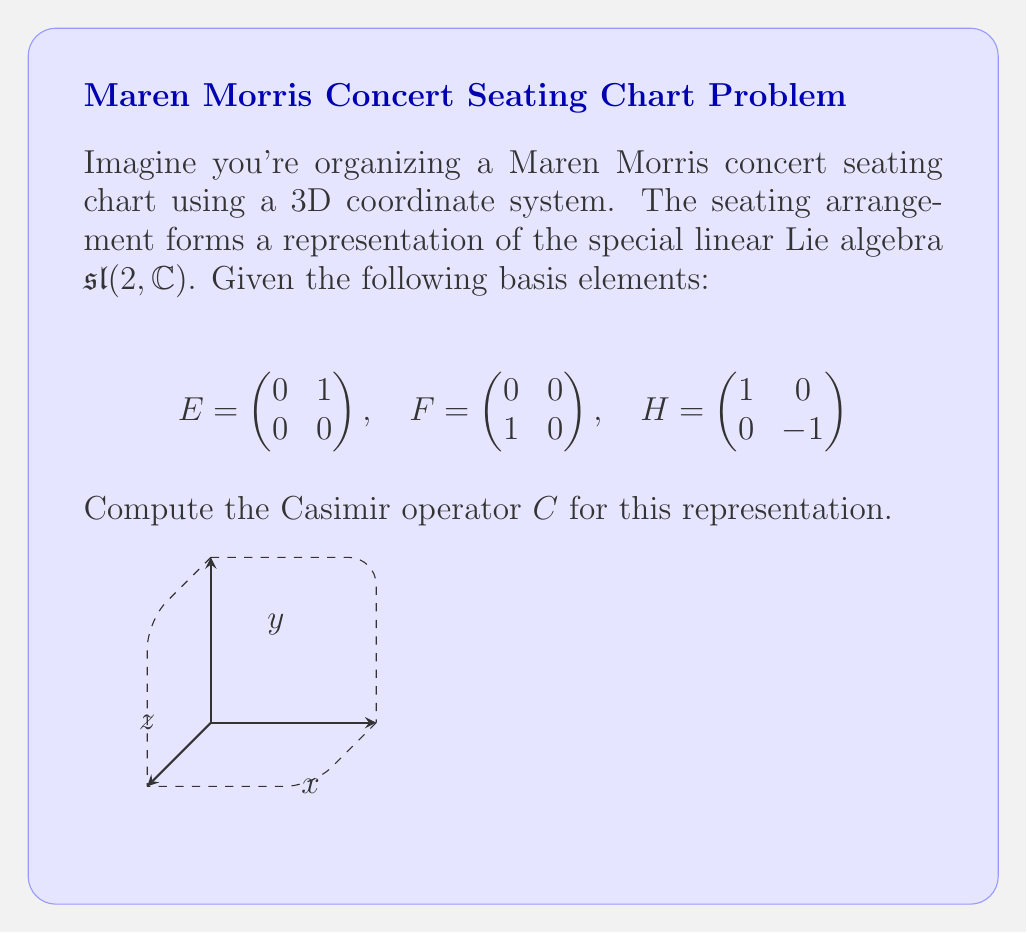Teach me how to tackle this problem. To compute the Casimir operator for this representation of $\mathfrak{sl}(2,\mathbb{C})$, we'll follow these steps:

1) The general form of the Casimir operator for $\mathfrak{sl}(2,\mathbb{C})$ is:

   $$C = H^2 + 2(EF + FE)$$

2) We need to calculate $H^2$, $EF$, and $FE$:

   $H^2 = \begin{pmatrix} 1 & 0 \\ 0 & -1 \end{pmatrix} \begin{pmatrix} 1 & 0 \\ 0 & -1 \end{pmatrix} = \begin{pmatrix} 1 & 0 \\ 0 & 1 \end{pmatrix}$

   $EF = \begin{pmatrix} 0 & 1 \\ 0 & 0 \end{pmatrix} \begin{pmatrix} 0 & 0 \\ 1 & 0 \end{pmatrix} = \begin{pmatrix} 1 & 0 \\ 0 & 0 \end{pmatrix}$

   $FE = \begin{pmatrix} 0 & 0 \\ 1 & 0 \end{pmatrix} \begin{pmatrix} 0 & 1 \\ 0 & 0 \end{pmatrix} = \begin{pmatrix} 0 & 0 \\ 0 & 1 \end{pmatrix}$

3) Now, we can substitute these results into the Casimir operator formula:

   $$C = H^2 + 2(EF + FE)$$
   
   $$C = \begin{pmatrix} 1 & 0 \\ 0 & 1 \end{pmatrix} + 2\left(\begin{pmatrix} 1 & 0 \\ 0 & 0 \end{pmatrix} + \begin{pmatrix} 0 & 0 \\ 0 & 1 \end{pmatrix}\right)$$

4) Simplifying:

   $$C = \begin{pmatrix} 1 & 0 \\ 0 & 1 \end{pmatrix} + \begin{pmatrix} 2 & 0 \\ 0 & 2 \end{pmatrix} = \begin{pmatrix} 3 & 0 \\ 0 & 3 \end{pmatrix}$$

5) The result is a scalar multiple of the identity matrix, which is a characteristic property of the Casimir operator.
Answer: $C = 3I_2 = \begin{pmatrix} 3 & 0 \\ 0 & 3 \end{pmatrix}$ 